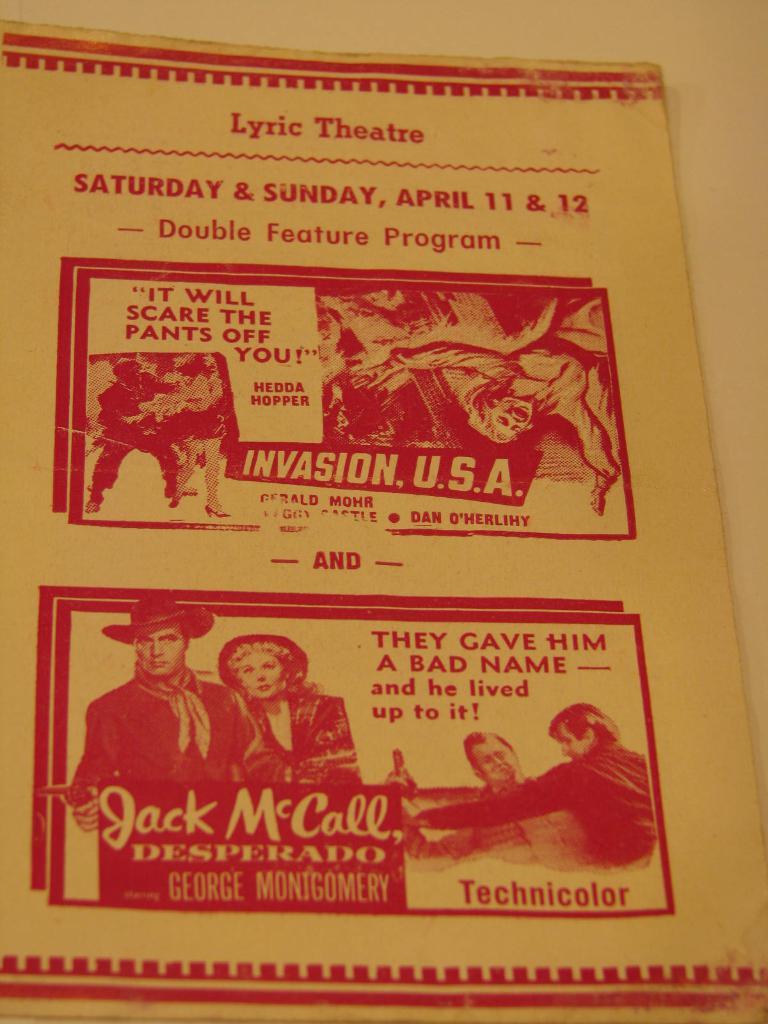What is the name of the theatre?
Ensure brevity in your answer.  Lyric. What is the name of the play?
Provide a short and direct response. Invasion usa. 